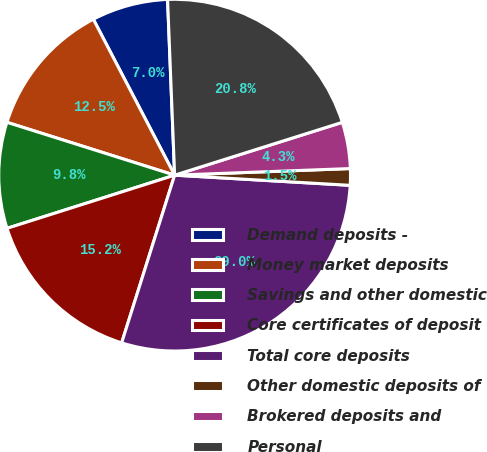<chart> <loc_0><loc_0><loc_500><loc_500><pie_chart><fcel>Demand deposits -<fcel>Money market deposits<fcel>Savings and other domestic<fcel>Core certificates of deposit<fcel>Total core deposits<fcel>Other domestic deposits of<fcel>Brokered deposits and<fcel>Personal<nl><fcel>7.01%<fcel>12.49%<fcel>9.75%<fcel>15.24%<fcel>28.95%<fcel>1.52%<fcel>4.26%<fcel>20.78%<nl></chart> 